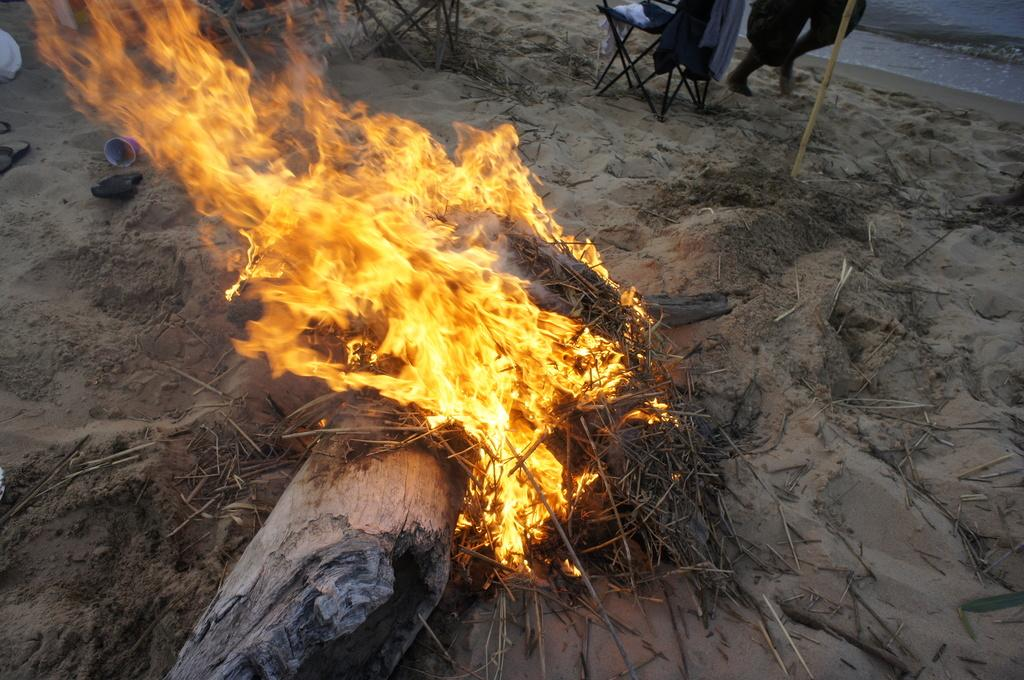What type of furniture is present in the image? There are chairs in the image. What is the wooden object in the image? There is a wooden trunk in the image. What is the source of fire in the image? There are stems with fire in the image. What is the ground made of in the image? There are other objects on the sand in the image. Can you see any part of a person in the image? Yes, there are legs of a person visible in the image. What is the liquid element in the image? There is water in the image. What type of insect can be seen crawling on the wooden trunk in the image? There is no insect visible on the wooden trunk in the image. What stage of development is the person in the image going through? There is no indication of the person's developmental stage in the image. 